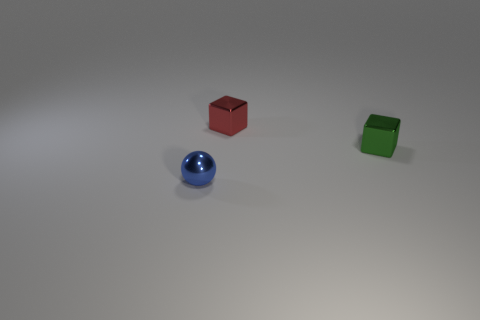How many other objects are there of the same material as the small red thing?
Your answer should be very brief. 2. What size is the red metallic object that is the same shape as the green object?
Your answer should be very brief. Small. Are the small blue sphere in front of the green cube and the tiny block that is in front of the red object made of the same material?
Your answer should be very brief. Yes. Are there fewer green metal cubes that are on the left side of the small green metal object than small green shiny cubes?
Provide a succinct answer. Yes. Is there any other thing that has the same shape as the green metallic object?
Keep it short and to the point. Yes. There is another small metal thing that is the same shape as the red object; what is its color?
Offer a very short reply. Green. There is a cube that is on the left side of the green metal thing; does it have the same size as the green shiny cube?
Keep it short and to the point. Yes. What is the size of the thing that is in front of the tiny shiny cube that is in front of the red cube?
Ensure brevity in your answer.  Small. Are the ball and the block behind the small green thing made of the same material?
Offer a terse response. Yes. Is the number of objects that are in front of the metal sphere less than the number of green things in front of the small green object?
Make the answer very short. No. 